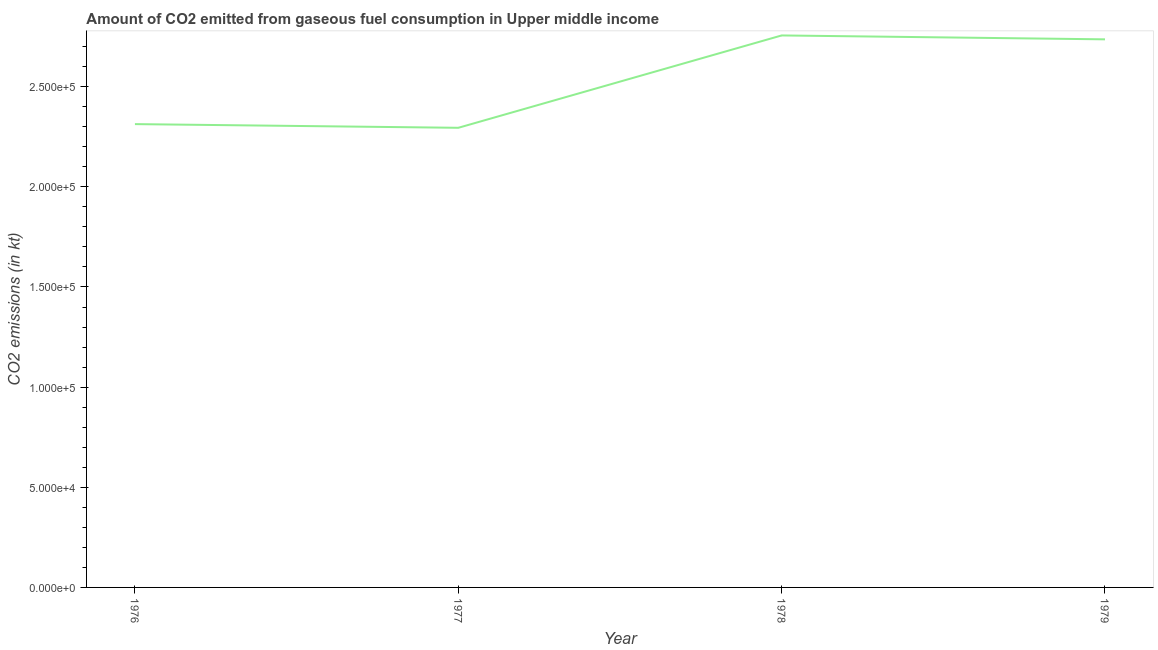What is the co2 emissions from gaseous fuel consumption in 1977?
Provide a short and direct response. 2.29e+05. Across all years, what is the maximum co2 emissions from gaseous fuel consumption?
Your response must be concise. 2.76e+05. Across all years, what is the minimum co2 emissions from gaseous fuel consumption?
Your answer should be compact. 2.29e+05. In which year was the co2 emissions from gaseous fuel consumption maximum?
Offer a very short reply. 1978. What is the sum of the co2 emissions from gaseous fuel consumption?
Your response must be concise. 1.01e+06. What is the difference between the co2 emissions from gaseous fuel consumption in 1976 and 1979?
Give a very brief answer. -4.23e+04. What is the average co2 emissions from gaseous fuel consumption per year?
Give a very brief answer. 2.52e+05. What is the median co2 emissions from gaseous fuel consumption?
Offer a terse response. 2.52e+05. In how many years, is the co2 emissions from gaseous fuel consumption greater than 100000 kt?
Your answer should be very brief. 4. What is the ratio of the co2 emissions from gaseous fuel consumption in 1976 to that in 1979?
Provide a succinct answer. 0.85. What is the difference between the highest and the second highest co2 emissions from gaseous fuel consumption?
Keep it short and to the point. 1947.53. Is the sum of the co2 emissions from gaseous fuel consumption in 1976 and 1978 greater than the maximum co2 emissions from gaseous fuel consumption across all years?
Give a very brief answer. Yes. What is the difference between the highest and the lowest co2 emissions from gaseous fuel consumption?
Your answer should be compact. 4.61e+04. In how many years, is the co2 emissions from gaseous fuel consumption greater than the average co2 emissions from gaseous fuel consumption taken over all years?
Keep it short and to the point. 2. How many lines are there?
Your answer should be compact. 1. What is the title of the graph?
Give a very brief answer. Amount of CO2 emitted from gaseous fuel consumption in Upper middle income. What is the label or title of the X-axis?
Give a very brief answer. Year. What is the label or title of the Y-axis?
Give a very brief answer. CO2 emissions (in kt). What is the CO2 emissions (in kt) of 1976?
Your response must be concise. 2.31e+05. What is the CO2 emissions (in kt) of 1977?
Provide a short and direct response. 2.29e+05. What is the CO2 emissions (in kt) in 1978?
Give a very brief answer. 2.76e+05. What is the CO2 emissions (in kt) in 1979?
Make the answer very short. 2.74e+05. What is the difference between the CO2 emissions (in kt) in 1976 and 1977?
Offer a very short reply. 1844.57. What is the difference between the CO2 emissions (in kt) in 1976 and 1978?
Make the answer very short. -4.43e+04. What is the difference between the CO2 emissions (in kt) in 1976 and 1979?
Give a very brief answer. -4.23e+04. What is the difference between the CO2 emissions (in kt) in 1977 and 1978?
Offer a terse response. -4.61e+04. What is the difference between the CO2 emissions (in kt) in 1977 and 1979?
Offer a very short reply. -4.42e+04. What is the difference between the CO2 emissions (in kt) in 1978 and 1979?
Offer a very short reply. 1947.53. What is the ratio of the CO2 emissions (in kt) in 1976 to that in 1978?
Give a very brief answer. 0.84. What is the ratio of the CO2 emissions (in kt) in 1976 to that in 1979?
Your answer should be compact. 0.84. What is the ratio of the CO2 emissions (in kt) in 1977 to that in 1978?
Your response must be concise. 0.83. What is the ratio of the CO2 emissions (in kt) in 1977 to that in 1979?
Offer a very short reply. 0.84. 